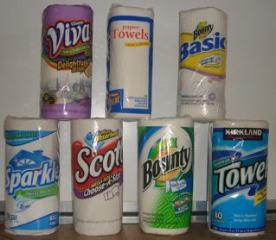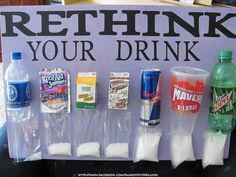The first image is the image on the left, the second image is the image on the right. Analyze the images presented: Is the assertion "One image shows an upright poster for a school science fair project, while a second image shows at least three wrapped rolls of paper towels, all different brands." valid? Answer yes or no. Yes. The first image is the image on the left, the second image is the image on the right. Analyze the images presented: Is the assertion "One image shows a poster with consumer items in front of it, and the other image shows individiually wrapped paper towel rolls." valid? Answer yes or no. Yes. 